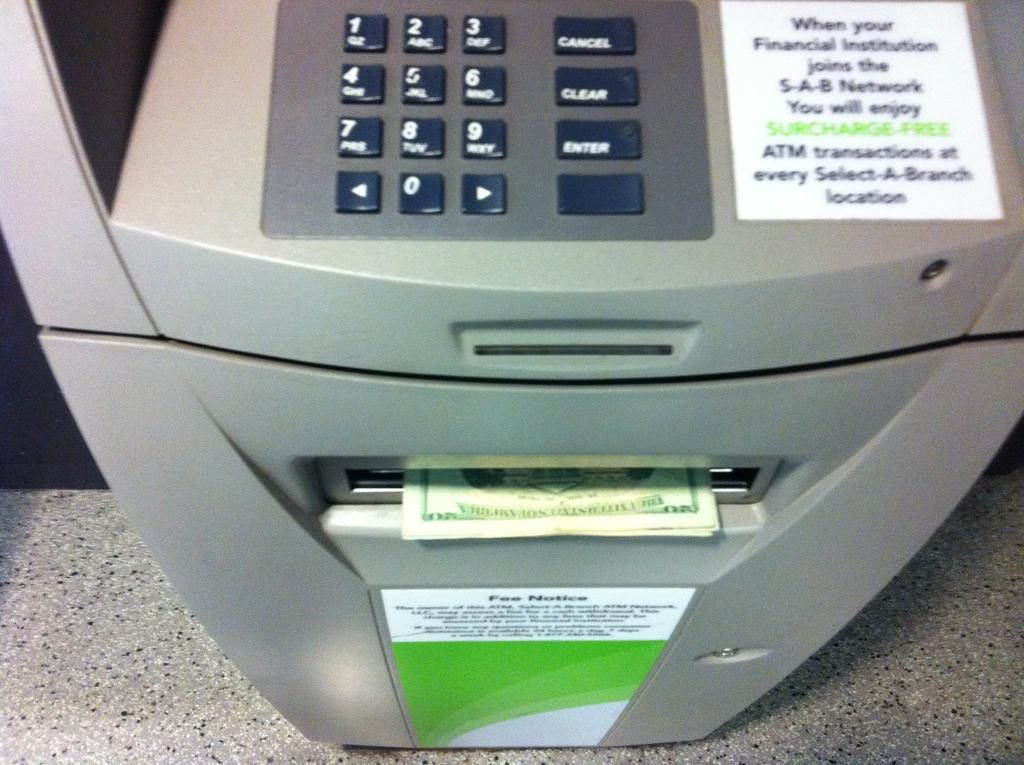<image>
Offer a succinct explanation of the picture presented. A surcharge-free ATM with a stack of 20 dollar bills coming out. 